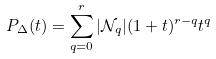<formula> <loc_0><loc_0><loc_500><loc_500>P _ { \Delta } ( t ) = \sum _ { q = 0 } ^ { r } | \mathcal { N } _ { q } | ( 1 + t ) ^ { r - q } t ^ { q }</formula> 